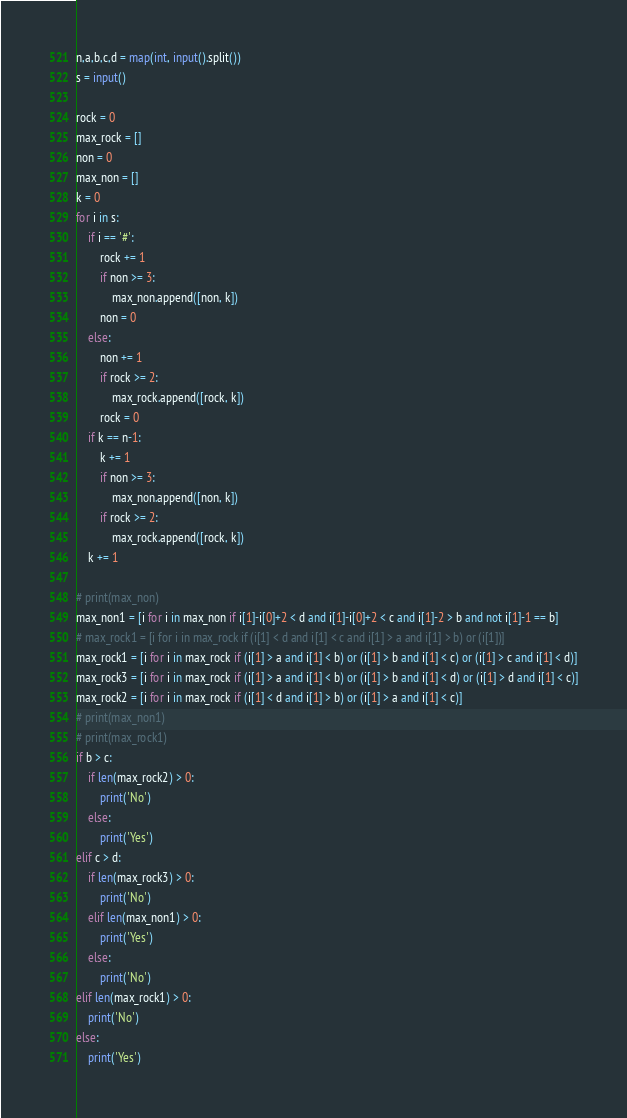<code> <loc_0><loc_0><loc_500><loc_500><_Python_>n,a,b,c,d = map(int, input().split())
s = input()

rock = 0
max_rock = []
non = 0
max_non = []
k = 0
for i in s:
    if i == '#':
        rock += 1
        if non >= 3:
            max_non.append([non, k])
        non = 0
    else:
        non += 1
        if rock >= 2:
            max_rock.append([rock, k])
        rock = 0
    if k == n-1:
        k += 1
        if non >= 3:
            max_non.append([non, k])
        if rock >= 2:
            max_rock.append([rock, k])
    k += 1

# print(max_non)
max_non1 = [i for i in max_non if i[1]-i[0]+2 < d and i[1]-i[0]+2 < c and i[1]-2 > b and not i[1]-1 == b]
# max_rock1 = [i for i in max_rock if (i[1] < d and i[1] < c and i[1] > a and i[1] > b) or (i[1])]
max_rock1 = [i for i in max_rock if (i[1] > a and i[1] < b) or (i[1] > b and i[1] < c) or (i[1] > c and i[1] < d)]
max_rock3 = [i for i in max_rock if (i[1] > a and i[1] < b) or (i[1] > b and i[1] < d) or (i[1] > d and i[1] < c)]
max_rock2 = [i for i in max_rock if (i[1] < d and i[1] > b) or (i[1] > a and i[1] < c)]
# print(max_non1)
# print(max_rock1)
if b > c:
    if len(max_rock2) > 0:
        print('No')
    else:
        print('Yes')
elif c > d:
    if len(max_rock3) > 0:
        print('No')
    elif len(max_non1) > 0:
        print('Yes')
    else:
        print('No')
elif len(max_rock1) > 0:
    print('No')
else:
    print('Yes')
</code> 